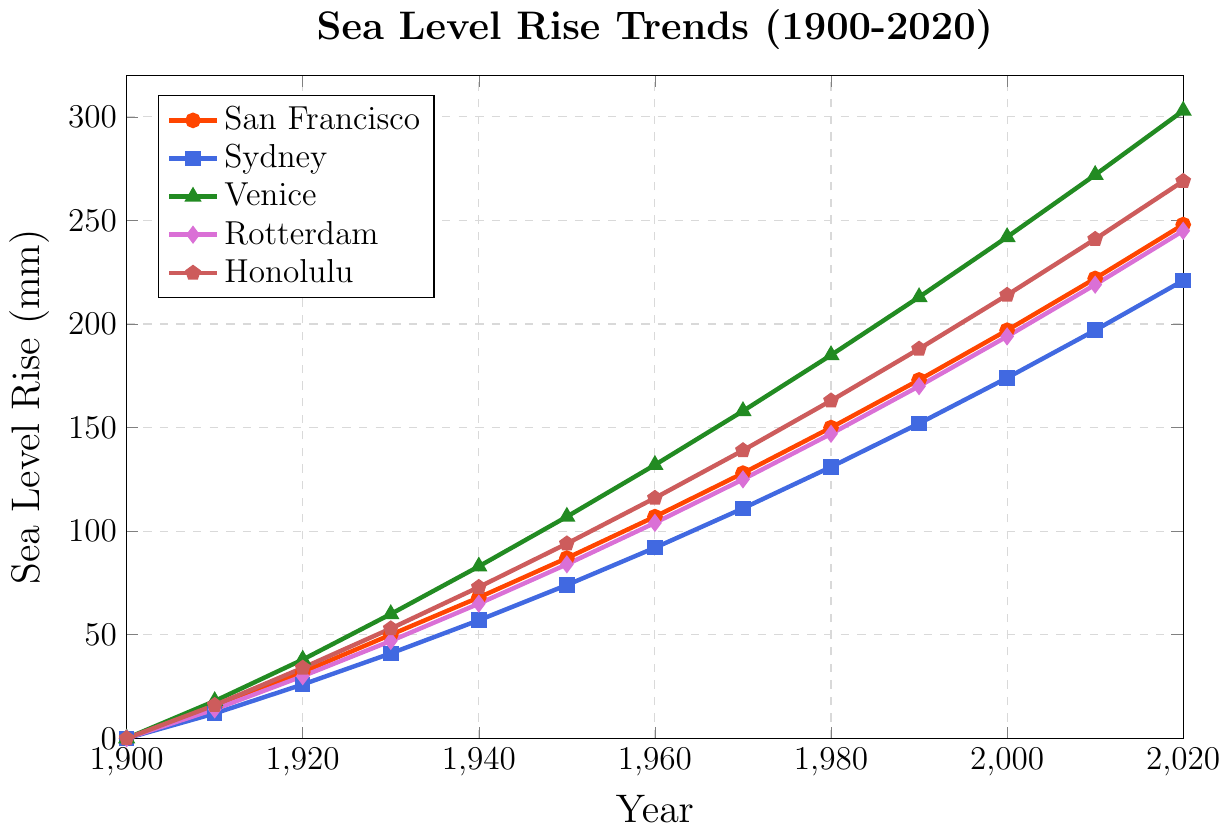What station shows the greatest sea level rise by 2020? To identify the station with the highest sea level rise, compare the values for San Francisco, Sydney, Venice, Rotterdam, and Honolulu in 2020. The values are 248 mm (San Francisco), 221 mm (Sydney), 303 mm (Venice), 245 mm (Rotterdam), and 269 mm (Honolulu). Venice has the highest value.
Answer: Venice Which coastal station had the smallest sea level rise in 1980? Check the sea level rise values in 1980 for all stations. The values are 150 mm (San Francisco), 131 mm (Sydney), 185 mm (Venice), 147 mm (Rotterdam), and 163 mm (Honolulu). Sydney has the smallest value.
Answer: Sydney How much more did the sea level rise in Honolulu compared to San Francisco in 1920? Determine the sea level rise for both cities in 1920, which are 34 mm (Honolulu) and 32 mm (San Francisco). Subtract the value of San Francisco from Honolulu: 34 - 32 = 2 mm.
Answer: 2 mm Which station showed the steepest relative increase in sea level rise from 1900 to 1910? Calculate the difference in sea level rise from 1900 to 1910 for each station: San Francisco (15 mm), Sydney (12 mm), Venice (18 mm), Rotterdam (14 mm), and Honolulu (16 mm). Venice has the highest increase.
Answer: Venice By how much did the average sea level rise change between 1950 and 1970 across all stations? Find the average sea level rise for all stations in 1950 and 1970. For 1950: (87 + 74 + 107 + 84 + 94)/5 = 89.2 mm. For 1970: (128 + 111 + 158 + 125 + 139)/5 = 132.2 mm. The change is 132.2 - 89.2 = 43 mm.
Answer: 43 mm What is the total sea level rise experienced by Venice from 1900 to 2020? Subtract Venice's sea level in 1900 (0 mm) from its sea level in 2020 (303 mm). Therefore, total sea level rise: 303 - 0 = 303 mm.
Answer: 303 mm Which two stations have the closest sea level rise values in 2020? Compare the 2020 values for all stations: San Francisco (248 mm), Sydney (221 mm), Venice (303 mm), Rotterdam (245 mm), and Honolulu (269 mm). The closest values are San Francisco and Rotterdam (248 mm and 245 mm, respectively), with a difference of 3 mm.
Answer: San Francisco and Rotterdam How did the sea level rise in Rotterdam compare in 1940 and 2000? Check the sea level rise values for Rotterdam in 1940 (65 mm) and 2000 (194 mm). There is a rise of 194 - 65 = 129 mm.
Answer: 129 mm 